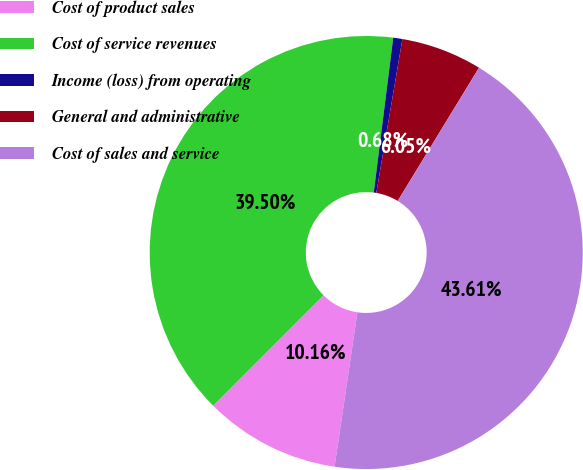Convert chart. <chart><loc_0><loc_0><loc_500><loc_500><pie_chart><fcel>Cost of product sales<fcel>Cost of service revenues<fcel>Income (loss) from operating<fcel>General and administrative<fcel>Cost of sales and service<nl><fcel>10.16%<fcel>39.5%<fcel>0.68%<fcel>6.05%<fcel>43.61%<nl></chart> 